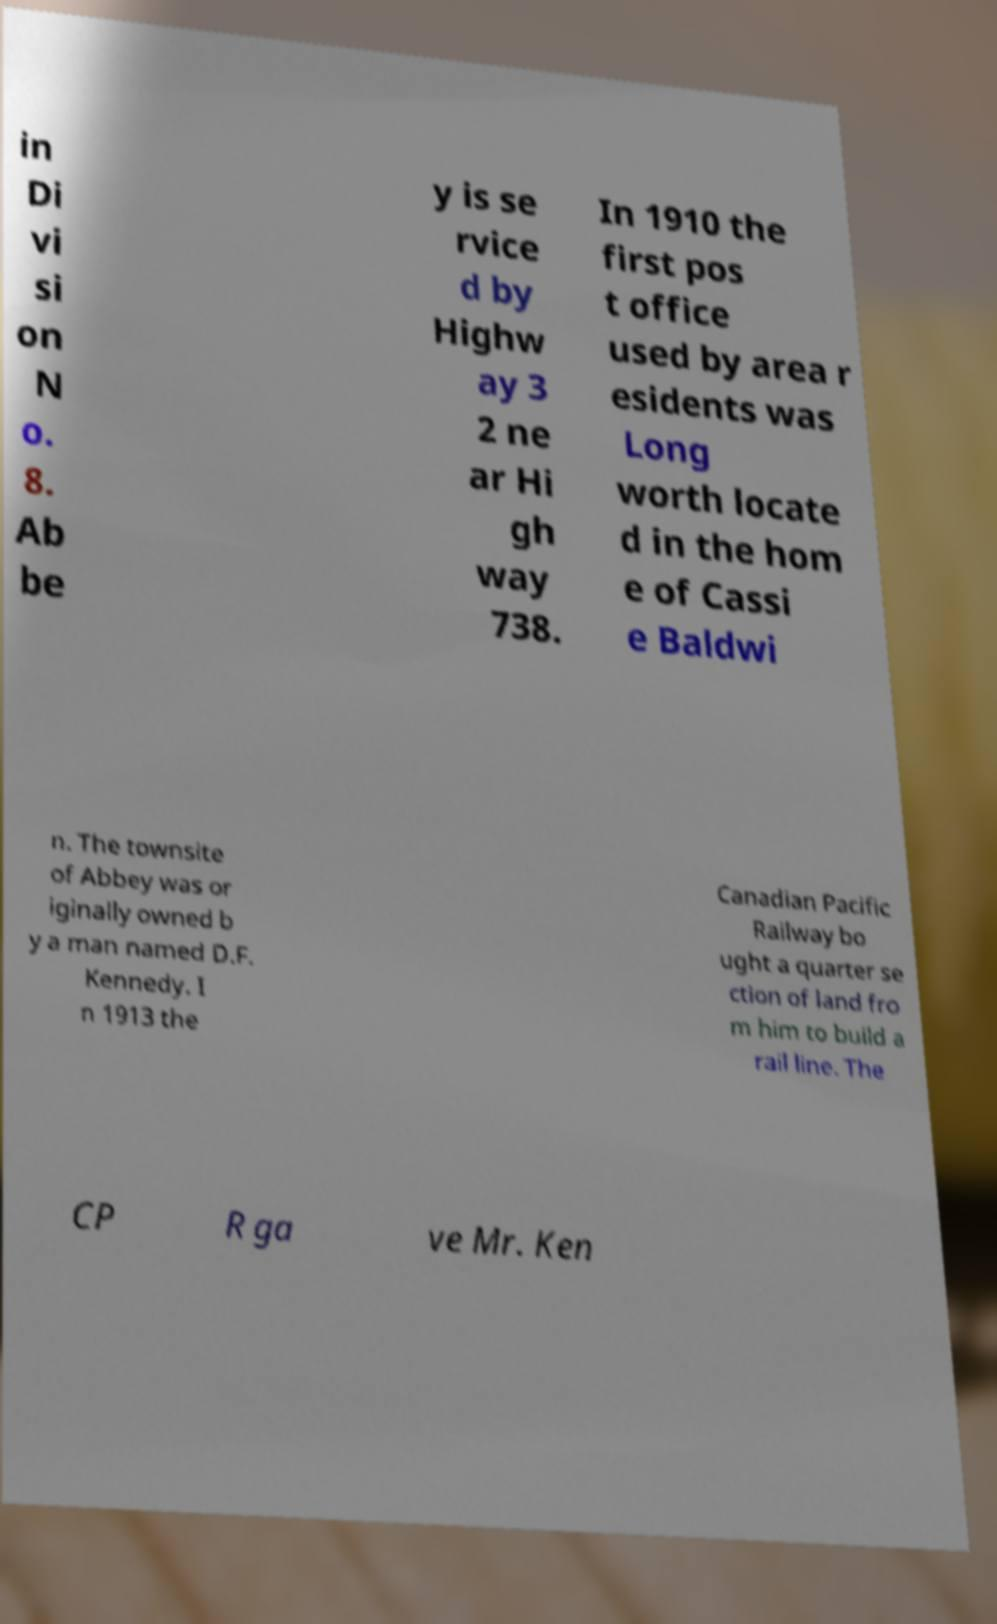What messages or text are displayed in this image? I need them in a readable, typed format. in Di vi si on N o. 8. Ab be y is se rvice d by Highw ay 3 2 ne ar Hi gh way 738. In 1910 the first pos t office used by area r esidents was Long worth locate d in the hom e of Cassi e Baldwi n. The townsite of Abbey was or iginally owned b y a man named D.F. Kennedy. I n 1913 the Canadian Pacific Railway bo ught a quarter se ction of land fro m him to build a rail line. The CP R ga ve Mr. Ken 